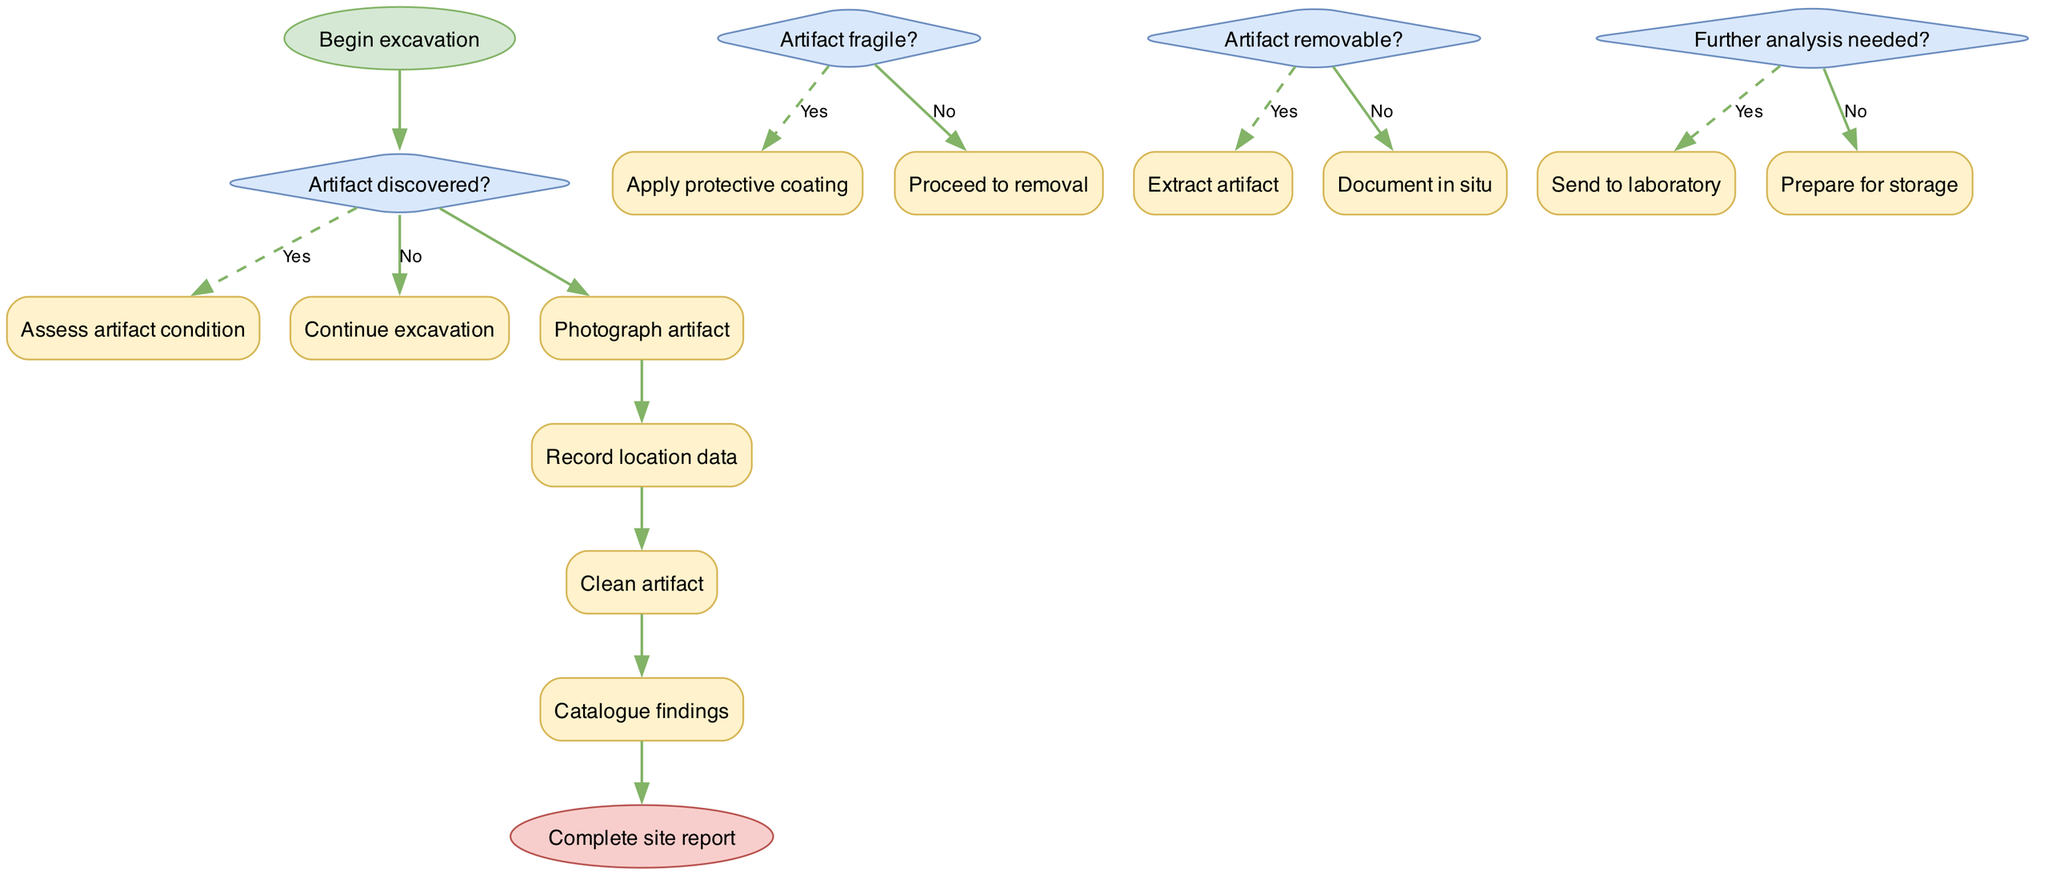What is the first step in the excavation process? The diagram starts with the node labeled "Begin excavation," which indicates the very first action to be taken.
Answer: Begin excavation How many decision nodes are present in the diagram? The diagram contains four decision nodes, each representing a question with "yes" or "no" branches.
Answer: Four What do we do if an "Artifact fragile?" decision leads to "Yes"? If the decision "Artifact fragile?" leads to "Yes," the next step is to "Apply protective coating" to ensure the artifact's safety.
Answer: Apply protective coating What happens after the "Extract artifact" process? After the process "Extract artifact," the flowchart indicates that the next step is to proceed to the "Complete site report" node, concluding the process.
Answer: Complete site report If an artifact is not removable, what should archaeologists do? When an artifact is determined to be not removable, the process indicates to "Document in situ," meaning to record the artifact's position in its original location.
Answer: Document in situ What is done after the "Photograph artifact" process? Following the "Photograph artifact" process, the next activity is to "Record location data," which is essential for cataloging the find.
Answer: Record location data What is the final stage in the excavation flowchart? The final stage in the flowchart is labeled "Complete site report," marking the end of the excavation process.
Answer: Complete site report Which action is taken if "Further analysis needed?" results in "Yes"? If "Further analysis needed?" results in "Yes," the flow proceeds to "Send to laboratory," where further examinations are conducted.
Answer: Send to laboratory What are the consequences of deciding "Artifact discovered?" with a "No"? When the decision "Artifact discovered?" results in "No," the flow continues back to "Continue excavation," indicating ongoing digging without interruption.
Answer: Continue excavation 